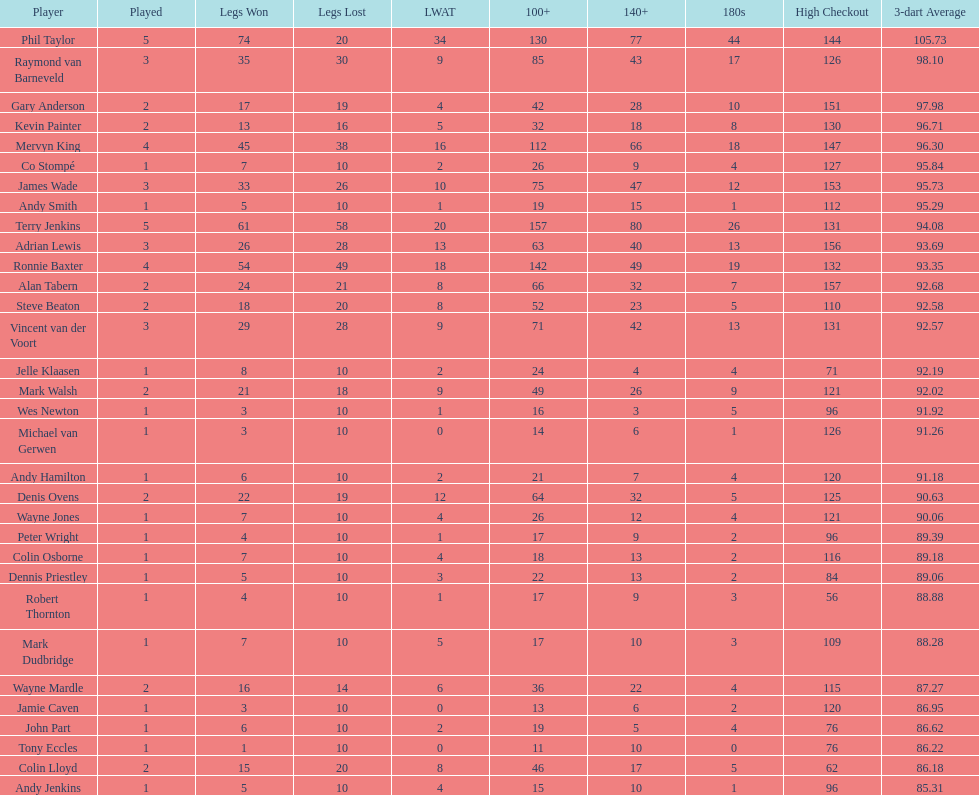What is the total amount of players who played more than 3 games? 4. 